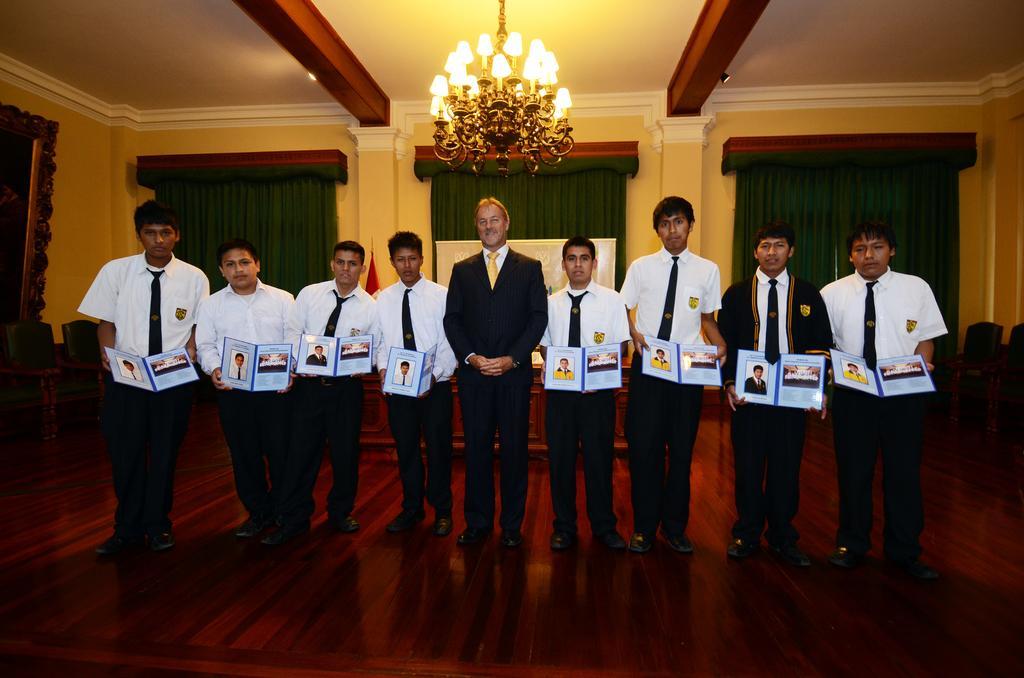In one or two sentences, can you explain what this image depicts? There are many people standing. Some are holding book. In the back there are curtains. On the ceiling there is a chandelier. On the left side there is a frame. In the background there are chairs. 